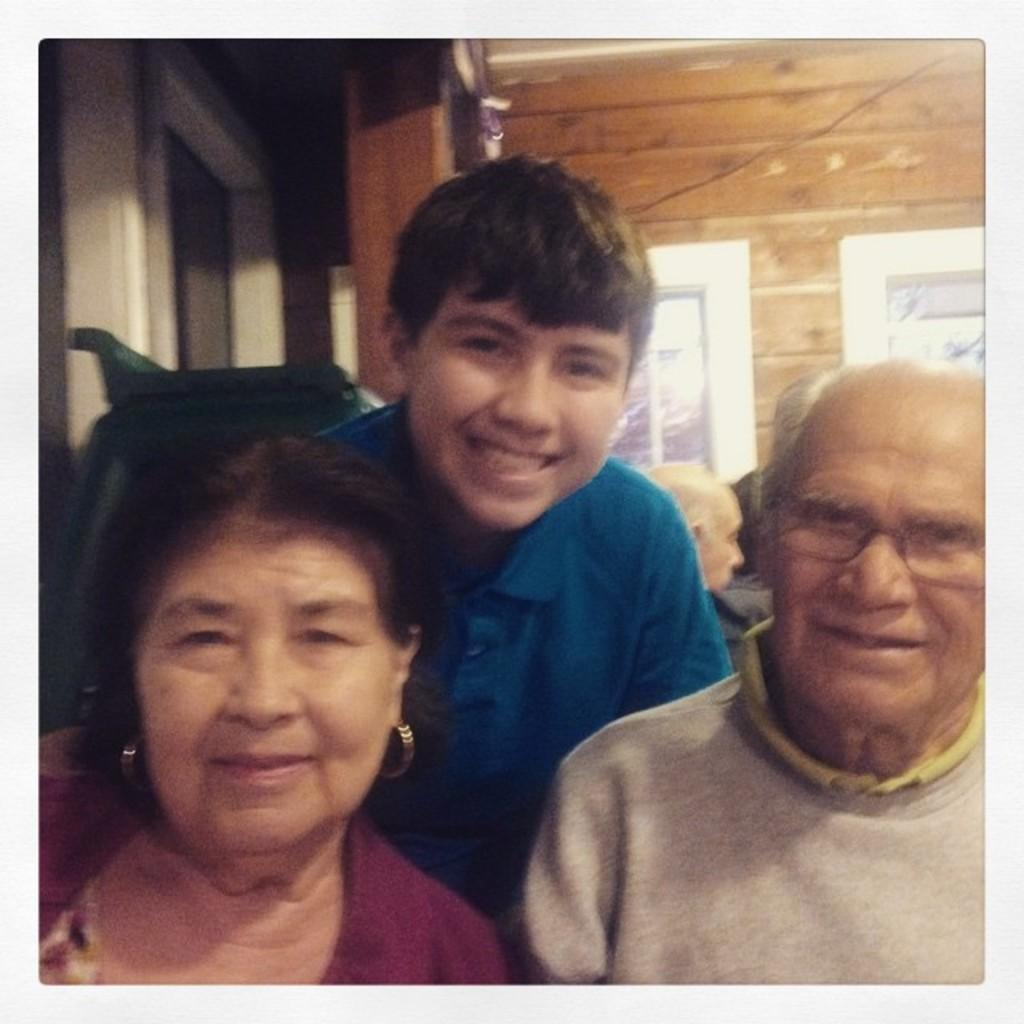How many people are visible in the image? There are three people in the image. What are the expressions on the faces of the people in the image? The three people are smiling. Can you describe the background of the image? There are other people and a wall in the background of the image. What type of science experiment is being conducted by the people in the image? There is no indication of a science experiment in the image; the people are simply smiling. 